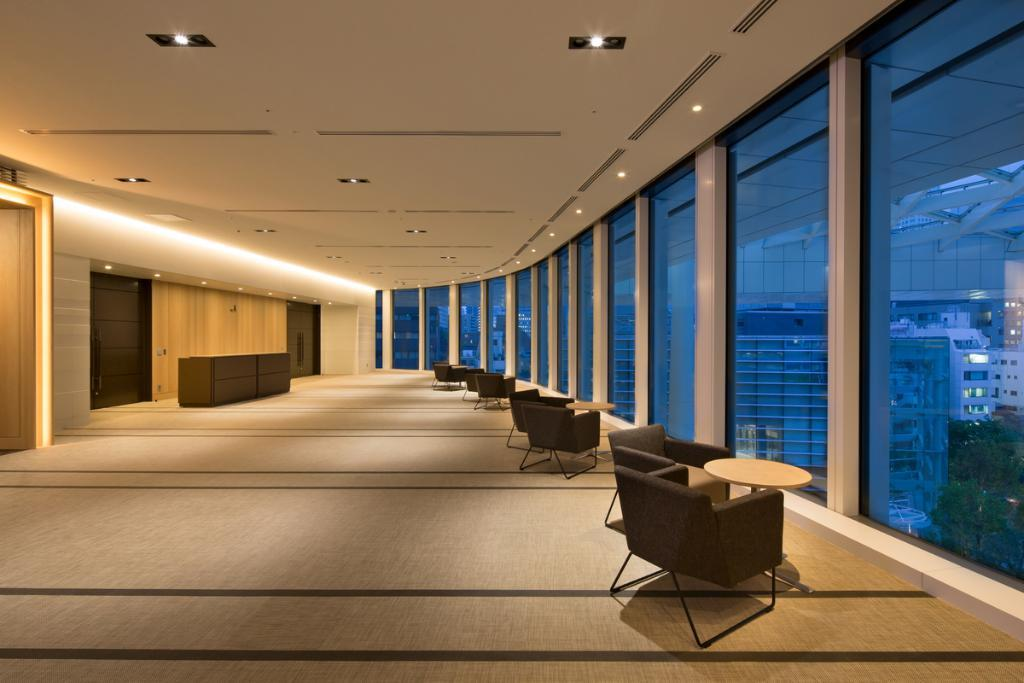What type of furniture is on the floor in the image? There are chairs and tables on the floor in the image. What can be seen through the windows in the image? Glass windows are visible in the image, but the view through them is not described in the facts. What is located at the top of the image? Lights are visible at the top of the image. What is in the background of the image? There is a wall, furniture, and doors in the background of the image. What type of crayon is being used to draw on the wall in the image? There is no crayon or drawing on the wall in the image. How many cabbages are on the table in the image? There are no cabbages present in the image. 